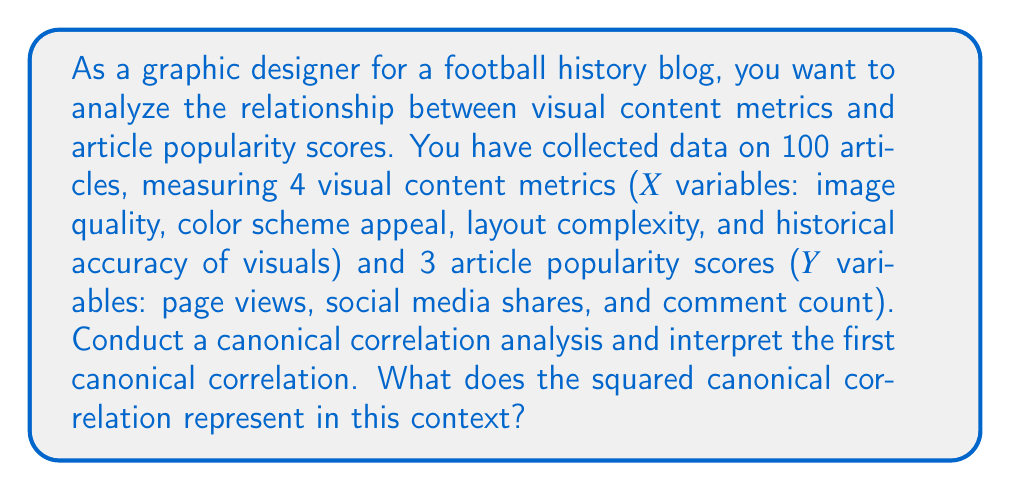Help me with this question. To conduct a canonical correlation analysis and interpret the results, follow these steps:

1. Prepare the data:
   Let $\mathbf{X}$ be the matrix of visual content metrics and $\mathbf{Y}$ be the matrix of article popularity scores.

2. Calculate the correlation matrices:
   $\mathbf{R_{xx}}$ : Correlation matrix of X variables
   $\mathbf{R_{yy}}$ : Correlation matrix of Y variables
   $\mathbf{R_{xy}}$ : Cross-correlation matrix between X and Y variables

3. Solve the eigenvalue equations:
   $$\mathbf{R_{xx}^{-1}R_{xy}R_{yy}^{-1}R_{yx}v} = \lambda^2 \mathbf{v}$$
   $$\mathbf{R_{yy}^{-1}R_{yx}R_{xx}^{-1}R_{xy}u} = \lambda^2 \mathbf{u}$$

   Where $\mathbf{v}$ and $\mathbf{u}$ are the eigenvectors, and $\lambda^2$ are the eigenvalues.

4. The first canonical correlation is the square root of the largest eigenvalue:
   $$r_c = \sqrt{\lambda_1^2}$$

5. Interpret the first canonical correlation:
   The first canonical correlation represents the maximum correlation between a linear combination of the visual content metrics and a linear combination of the article popularity scores.

6. Calculate the squared canonical correlation:
   $$r_c^2 = \lambda_1^2$$

The squared canonical correlation ($r_c^2$) represents the proportion of variance shared between the two sets of variables (visual content metrics and article popularity scores) for the first canonical variate pair. In this context, it indicates the strength of the relationship between the optimal linear combination of visual content metrics and the optimal linear combination of article popularity scores.

Specifically, $r_c^2$ represents the amount of variance in the article popularity scores that can be explained by the visual content metrics (and vice versa) through their respective linear combinations. It ranges from 0 to 1, where:

- A value close to 0 indicates a weak relationship between visual content metrics and article popularity scores.
- A value close to 1 indicates a strong relationship between visual content metrics and article popularity scores.

For example, if $r_c^2 = 0.64$, it means that 64% of the variance in the optimal linear combination of article popularity scores can be explained by the optimal linear combination of visual content metrics, and vice versa.
Answer: The squared canonical correlation ($r_c^2$) represents the proportion of shared variance between the optimal linear combination of visual content metrics and the optimal linear combination of article popularity scores. It indicates the strength of the relationship between these two sets of variables, ranging from 0 (no relationship) to 1 (perfect relationship). 